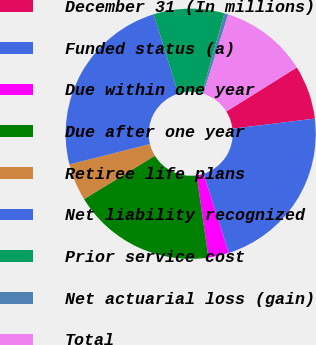<chart> <loc_0><loc_0><loc_500><loc_500><pie_chart><fcel>December 31 (In millions)<fcel>Funded status (a)<fcel>Due within one year<fcel>Due after one year<fcel>Retiree life plans<fcel>Net liability recognized<fcel>Prior service cost<fcel>Net actuarial loss (gain)<fcel>Total<nl><fcel>6.96%<fcel>22.01%<fcel>2.66%<fcel>18.51%<fcel>4.81%<fcel>24.16%<fcel>9.11%<fcel>0.51%<fcel>11.26%<nl></chart> 